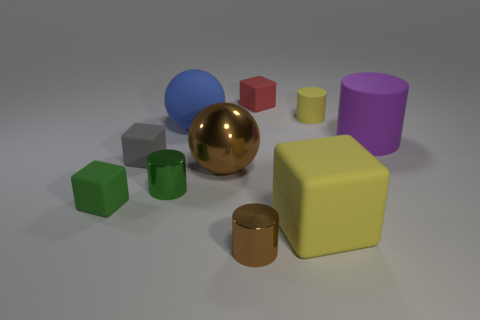Subtract all yellow cylinders. How many cylinders are left? 3 Add 1 yellow rubber balls. How many yellow rubber balls exist? 1 Subtract all yellow cylinders. How many cylinders are left? 3 Subtract 0 yellow spheres. How many objects are left? 10 Subtract all balls. How many objects are left? 8 Subtract 3 cubes. How many cubes are left? 1 Subtract all gray cylinders. Subtract all purple cubes. How many cylinders are left? 4 Subtract all brown cylinders. How many blue balls are left? 1 Subtract all big objects. Subtract all small brown metal cylinders. How many objects are left? 5 Add 1 tiny green metallic objects. How many tiny green metallic objects are left? 2 